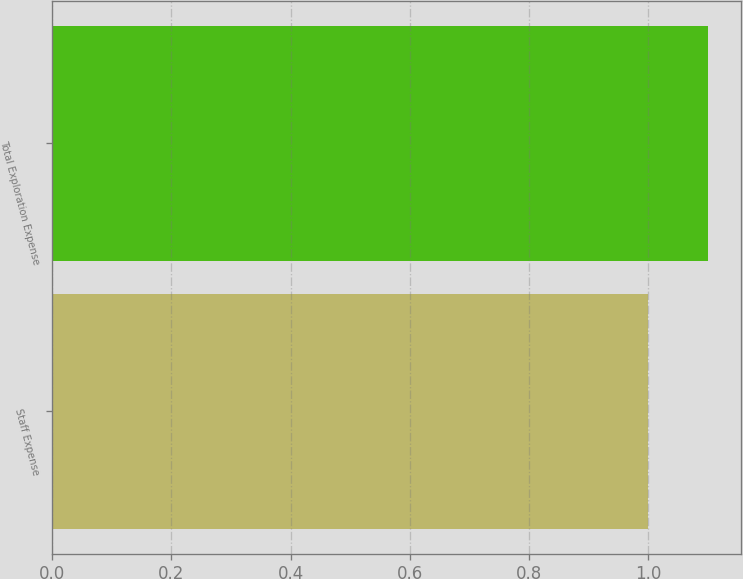Convert chart. <chart><loc_0><loc_0><loc_500><loc_500><bar_chart><fcel>Staff Expense<fcel>Total Exploration Expense<nl><fcel>1<fcel>1.1<nl></chart> 